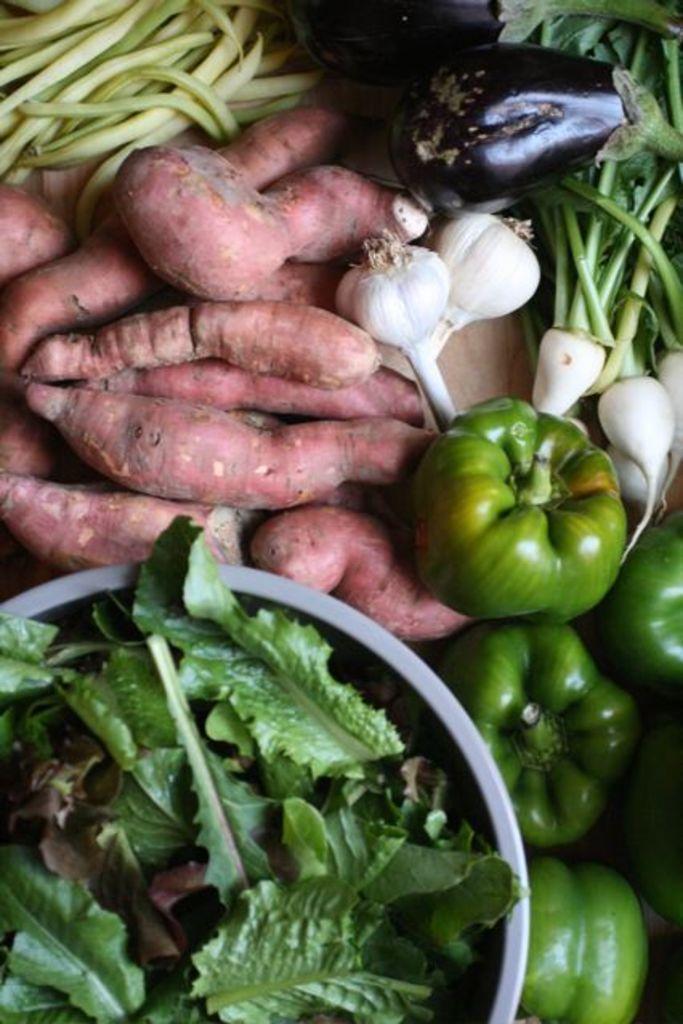Please provide a concise description of this image. In the foreground of this image, there are leafy vegetables in a bowl, capsicums, umbilical cords, beans, brinjal and the garlic on the wooden surface. 